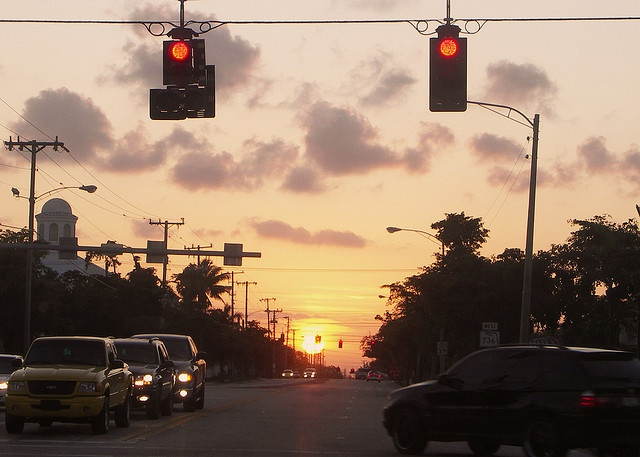Describe the objects in this image and their specific colors. I can see car in lightgray, black, gray, and maroon tones, car in lightgray, black, and gray tones, car in lightgray, black, gray, and maroon tones, traffic light in lightgray, maroon, black, beige, and red tones, and car in lightgray, black, maroon, and gray tones in this image. 